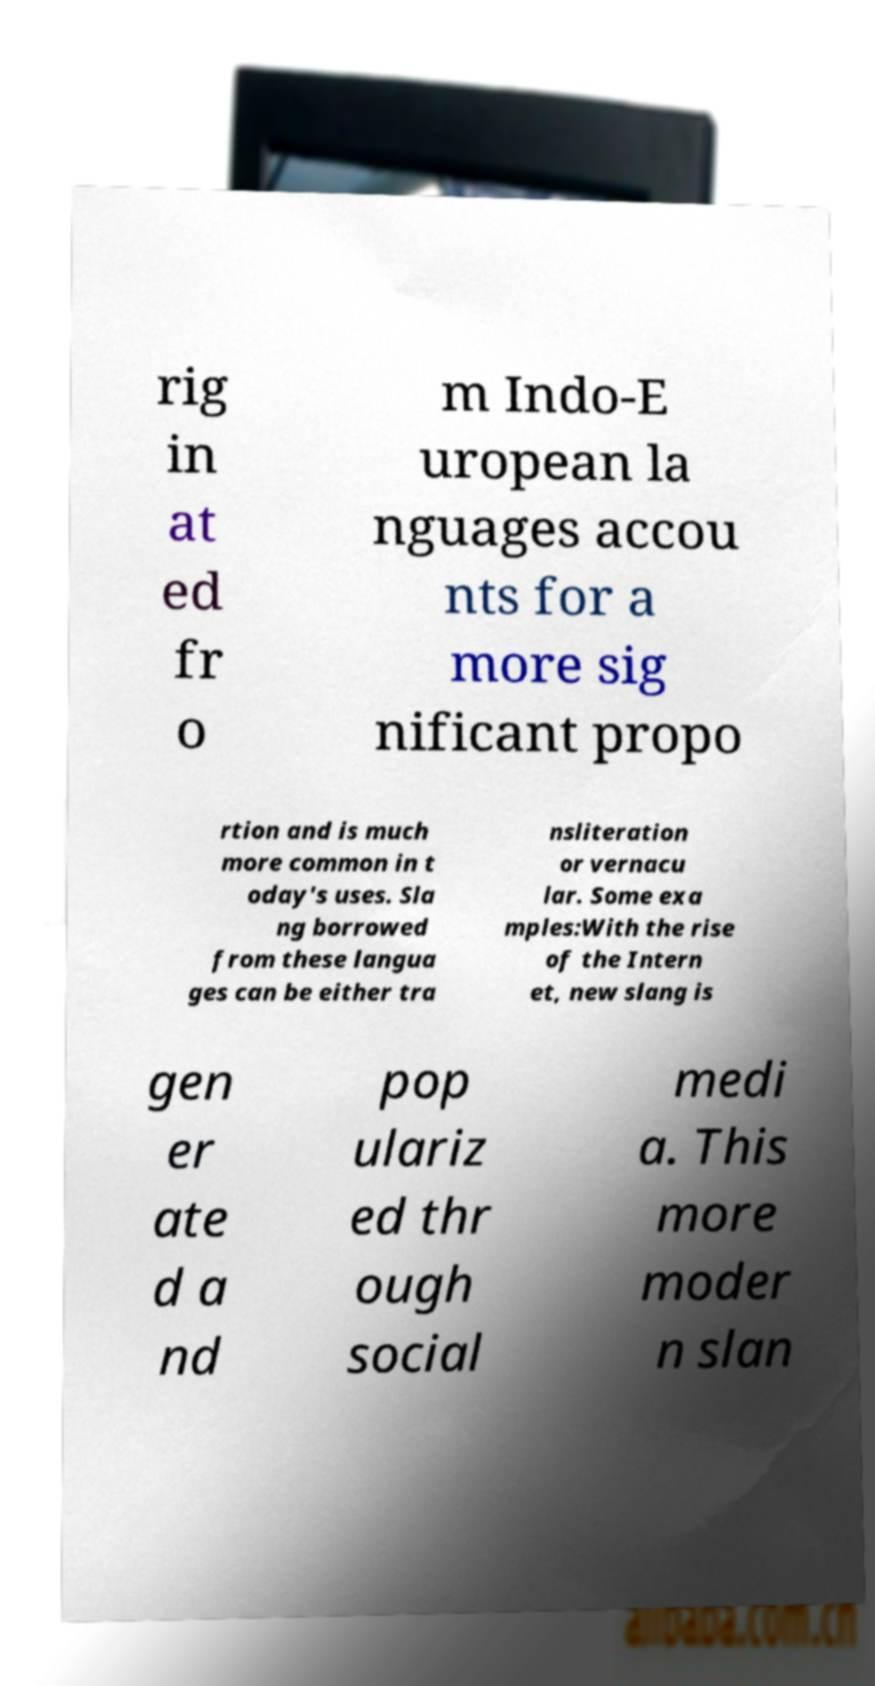Please read and relay the text visible in this image. What does it say? rig in at ed fr o m Indo-E uropean la nguages accou nts for a more sig nificant propo rtion and is much more common in t oday's uses. Sla ng borrowed from these langua ges can be either tra nsliteration or vernacu lar. Some exa mples:With the rise of the Intern et, new slang is gen er ate d a nd pop ulariz ed thr ough social medi a. This more moder n slan 